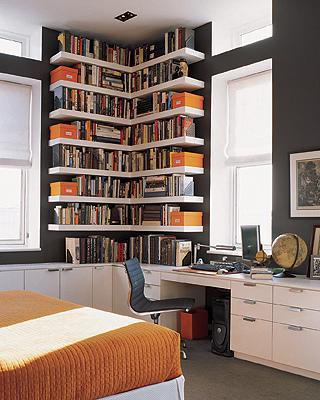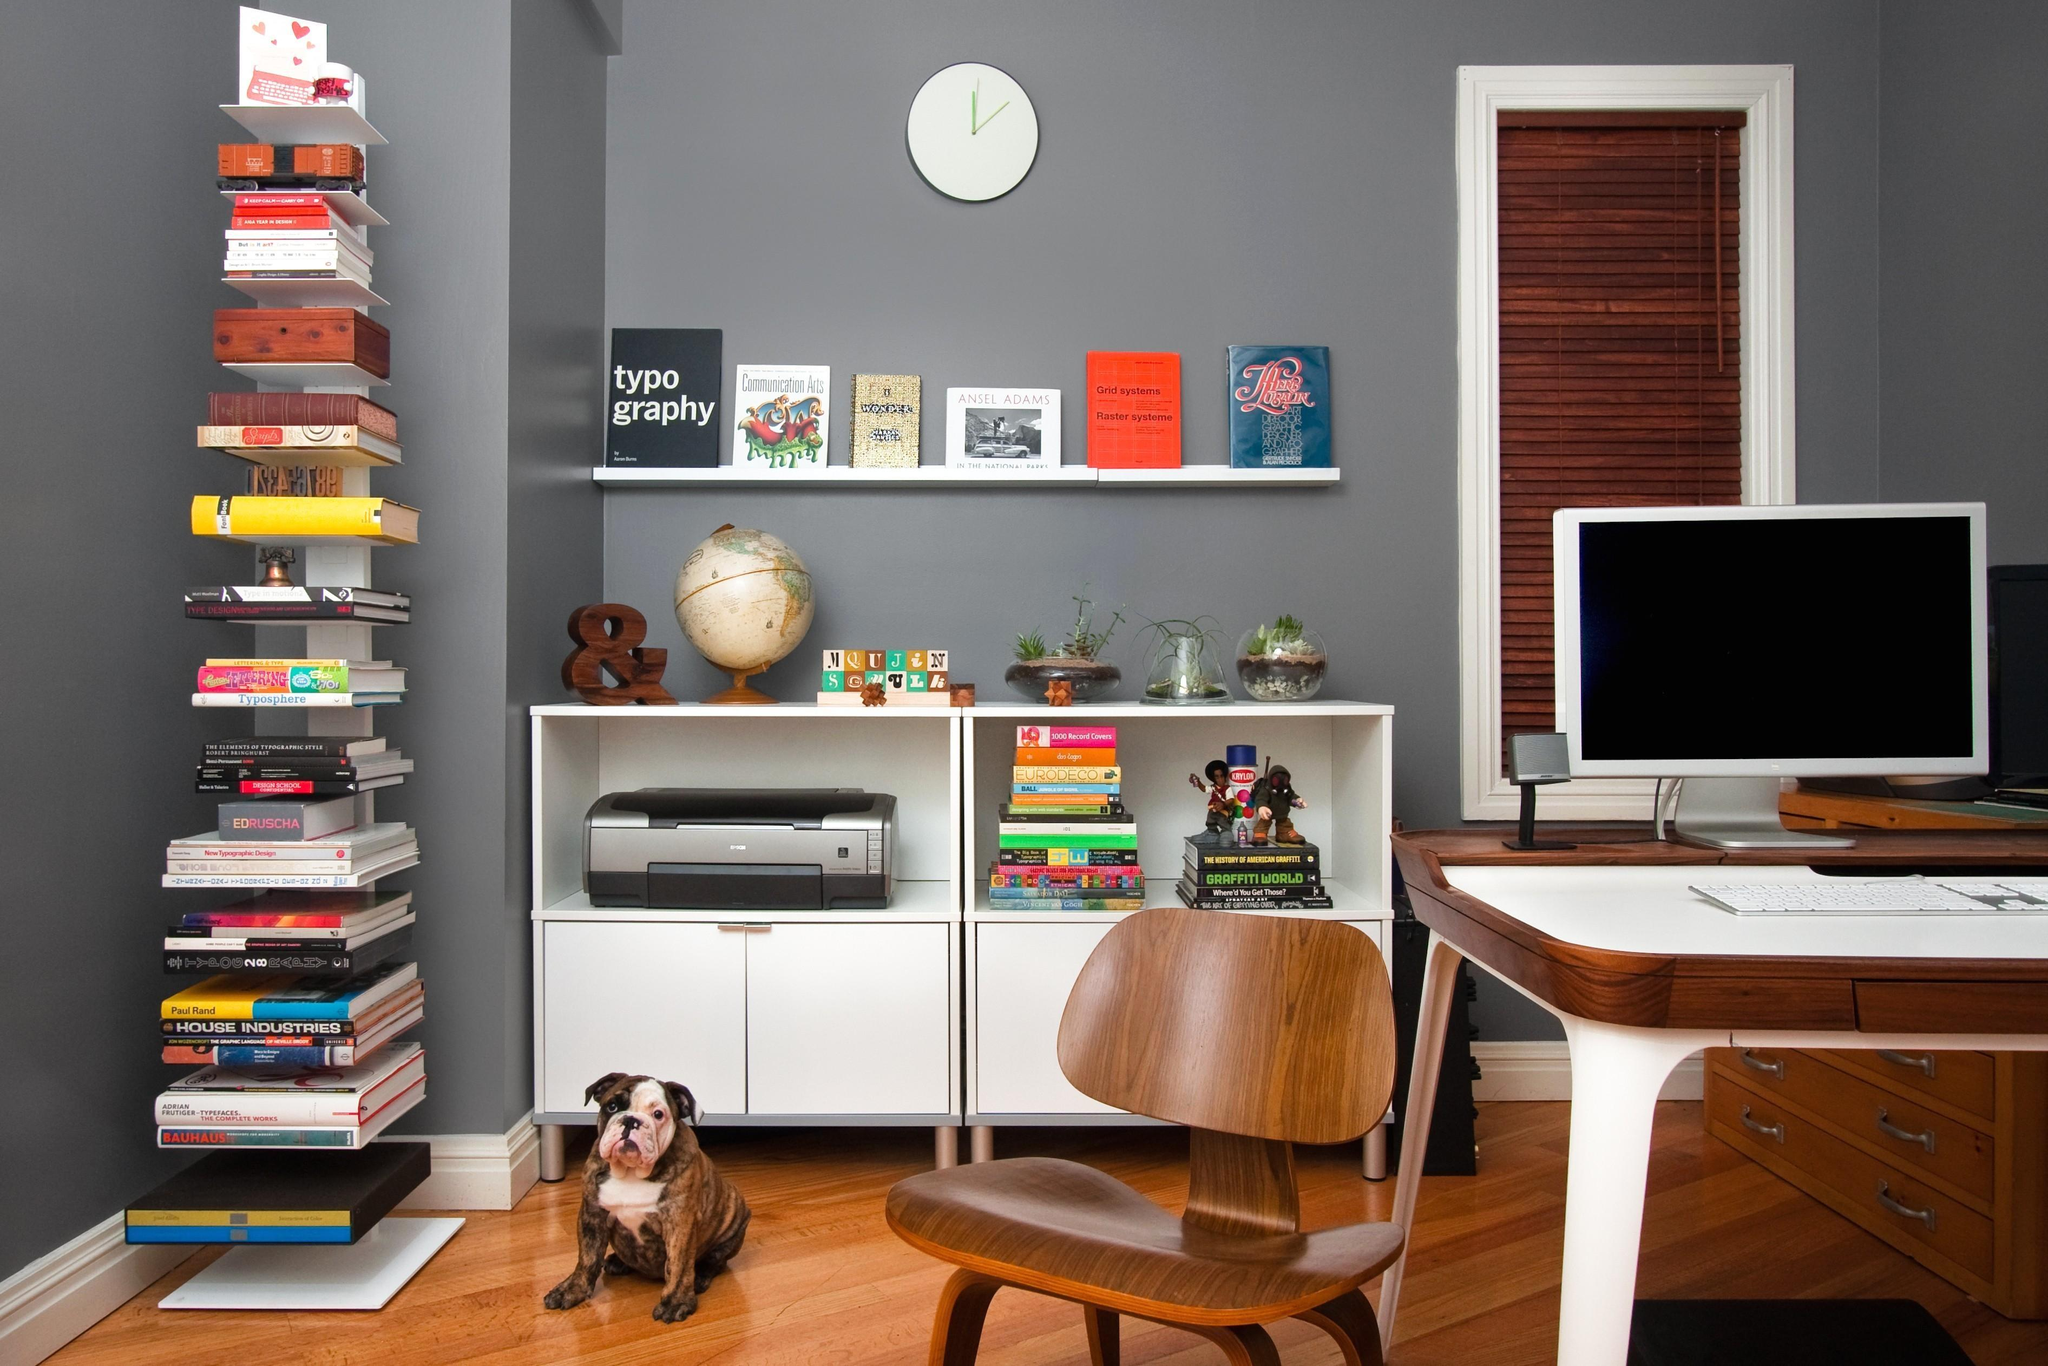The first image is the image on the left, the second image is the image on the right. For the images shown, is this caption "There is a potted plant sitting on the floor in the image on the left." true? Answer yes or no. No. 